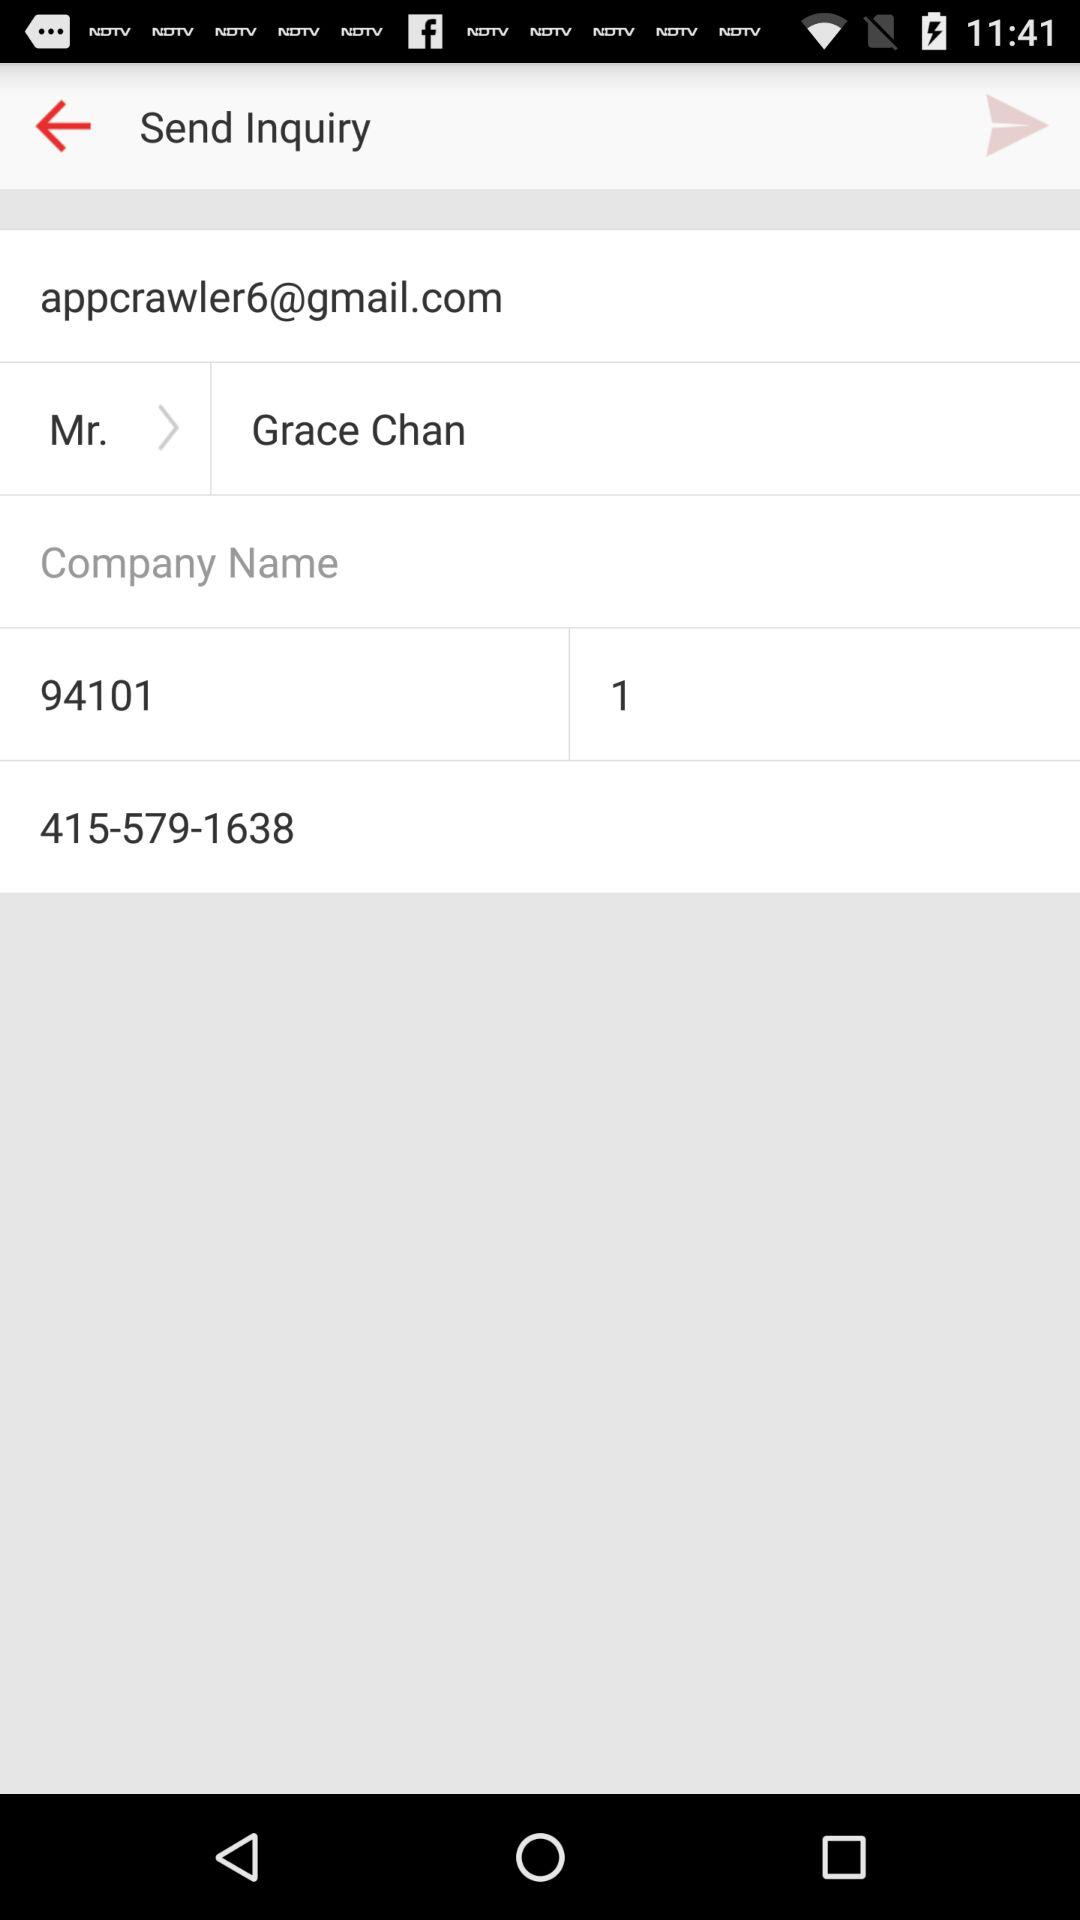What is the user name? The user name is Grace Chan. 